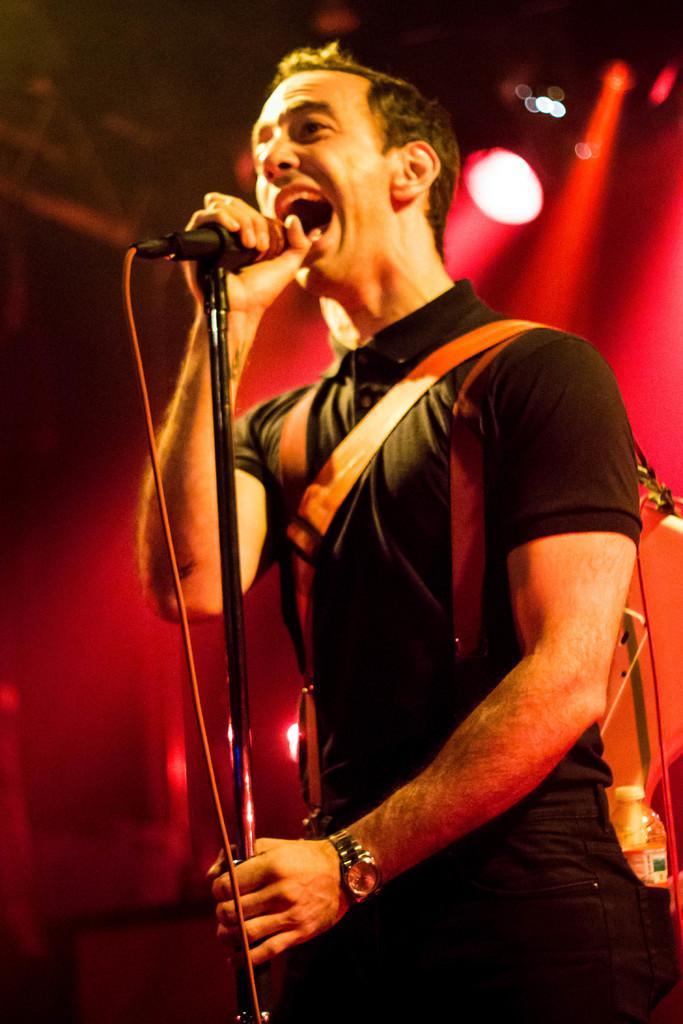Please provide a concise description of this image. In the foreground of this image, there is a man holding a mic and stand and also wearing a guitar. In the background, there is a red light. 